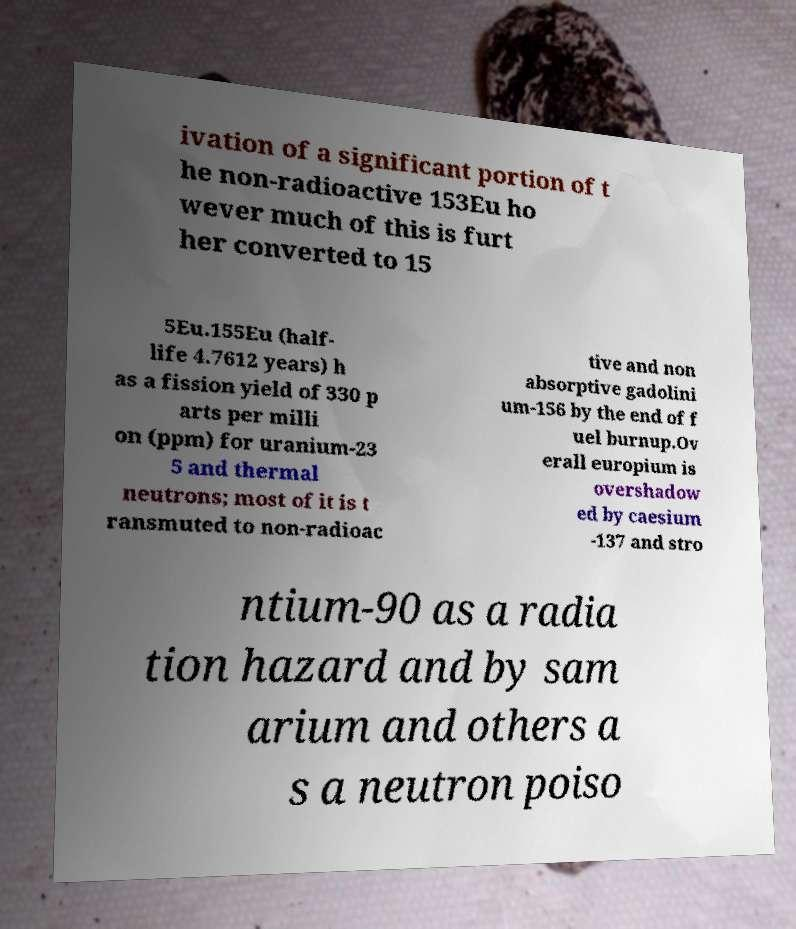Could you assist in decoding the text presented in this image and type it out clearly? ivation of a significant portion of t he non-radioactive 153Eu ho wever much of this is furt her converted to 15 5Eu.155Eu (half- life 4.7612 years) h as a fission yield of 330 p arts per milli on (ppm) for uranium-23 5 and thermal neutrons; most of it is t ransmuted to non-radioac tive and non absorptive gadolini um-156 by the end of f uel burnup.Ov erall europium is overshadow ed by caesium -137 and stro ntium-90 as a radia tion hazard and by sam arium and others a s a neutron poiso 